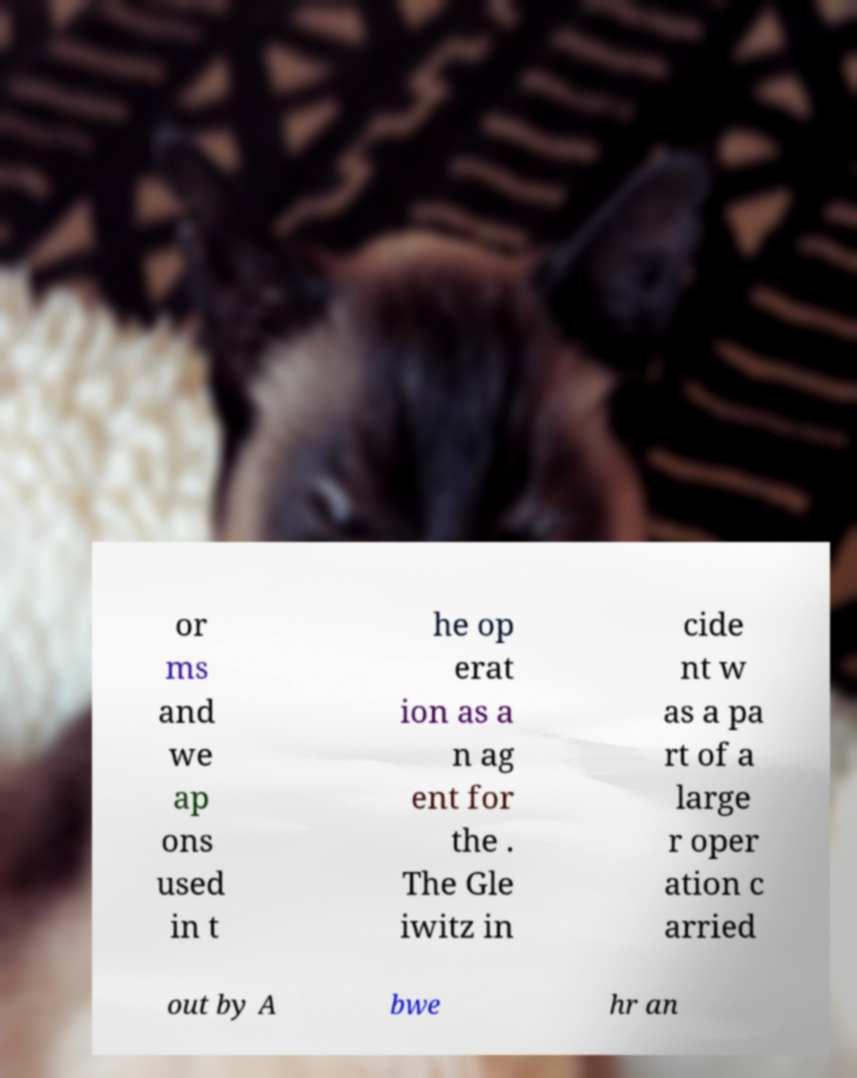Can you accurately transcribe the text from the provided image for me? or ms and we ap ons used in t he op erat ion as a n ag ent for the . The Gle iwitz in cide nt w as a pa rt of a large r oper ation c arried out by A bwe hr an 